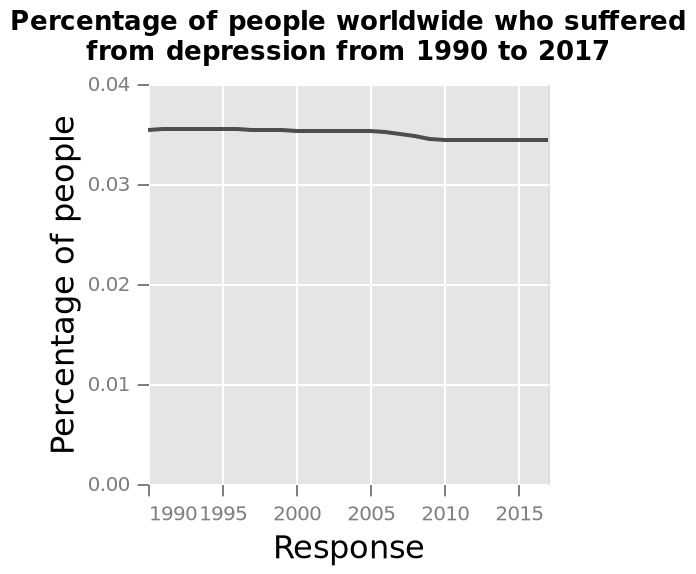<image>
What is the approximate percentage of people worldwide who suffered from depression between 1990 and 2017? The approximate percentage of people worldwide who suffered from depression between 1990 and 2017 is around 0.035%. What was the overall trend in the number of people suffering from depression between 1990 and 2017?  The overall trend in the number of people suffering from depression between 1990 and 2017 was relatively stable, with only a small decline between 2005 and 2010. 